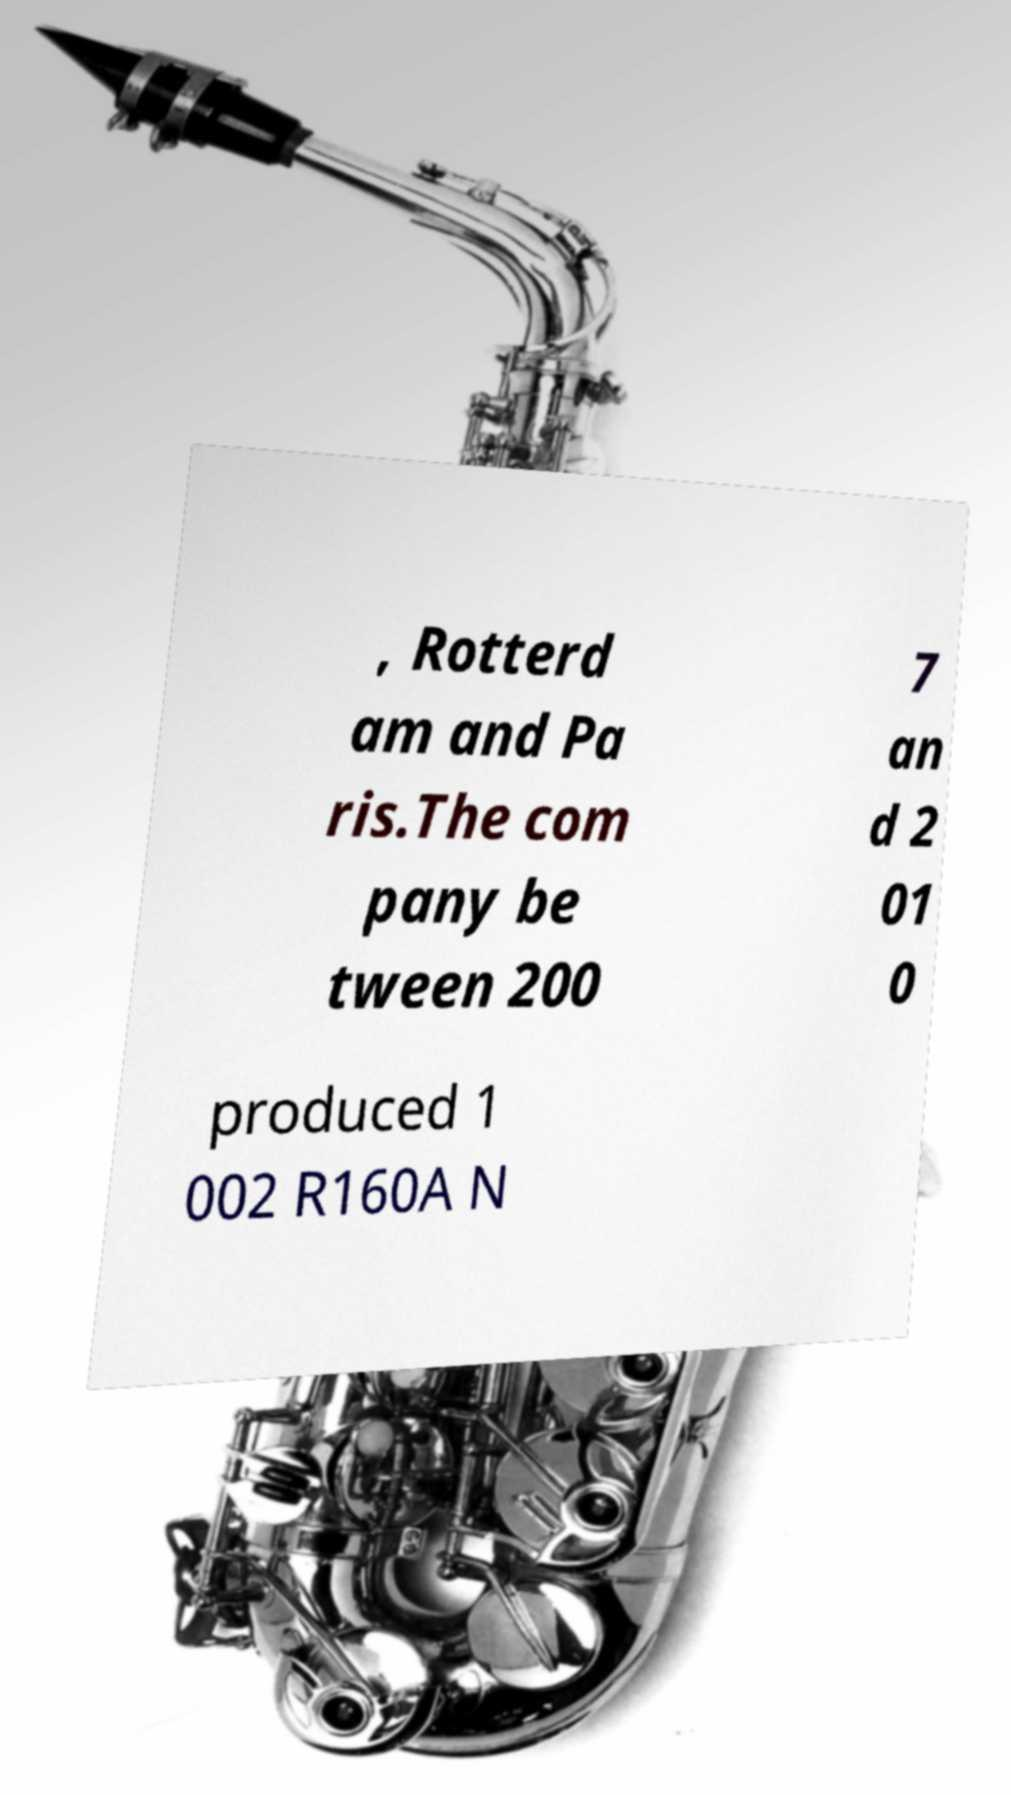Can you accurately transcribe the text from the provided image for me? , Rotterd am and Pa ris.The com pany be tween 200 7 an d 2 01 0 produced 1 002 R160A N 